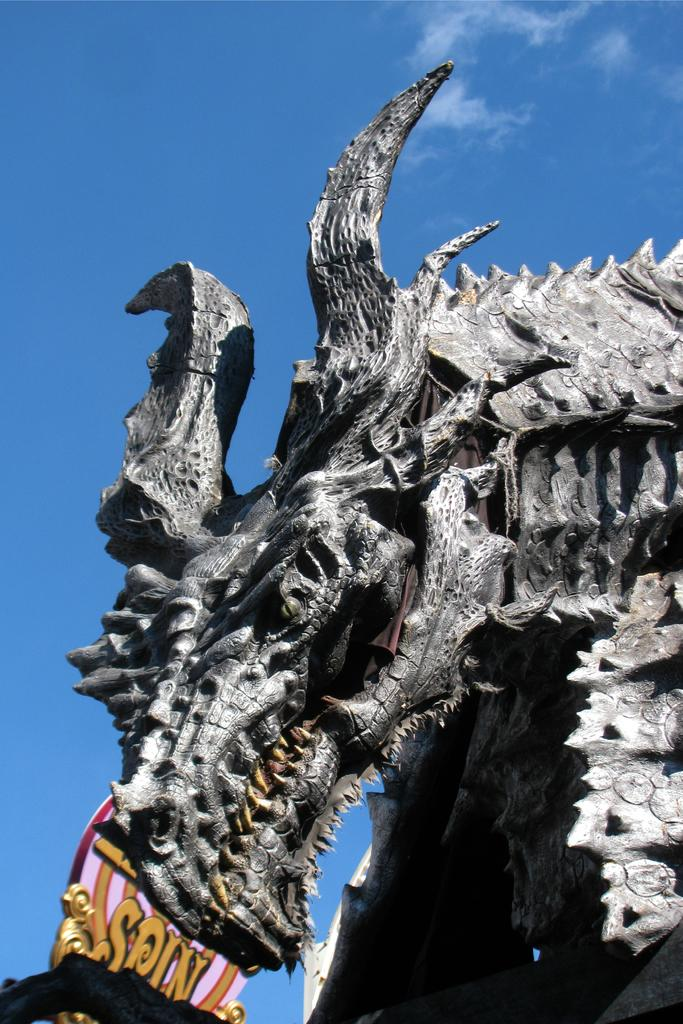What is the main subject of the image? The main subject of the image is a sculpture of a dragon. What is located behind the sculpture? There is an object with text behind the sculpture. What type of nose can be seen on the dragon sculpture? There is no nose visible on the dragon sculpture in the image. What caption is written on the object behind the sculpture? The provided facts do not mention a caption on the object behind the sculpture, so we cannot determine its content. 